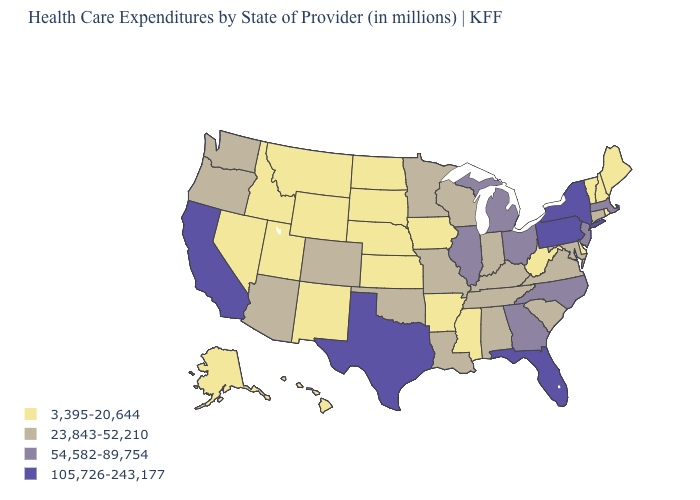Name the states that have a value in the range 105,726-243,177?
Short answer required. California, Florida, New York, Pennsylvania, Texas. Name the states that have a value in the range 3,395-20,644?
Give a very brief answer. Alaska, Arkansas, Delaware, Hawaii, Idaho, Iowa, Kansas, Maine, Mississippi, Montana, Nebraska, Nevada, New Hampshire, New Mexico, North Dakota, Rhode Island, South Dakota, Utah, Vermont, West Virginia, Wyoming. What is the value of Wyoming?
Answer briefly. 3,395-20,644. Which states have the lowest value in the USA?
Answer briefly. Alaska, Arkansas, Delaware, Hawaii, Idaho, Iowa, Kansas, Maine, Mississippi, Montana, Nebraska, Nevada, New Hampshire, New Mexico, North Dakota, Rhode Island, South Dakota, Utah, Vermont, West Virginia, Wyoming. Name the states that have a value in the range 3,395-20,644?
Give a very brief answer. Alaska, Arkansas, Delaware, Hawaii, Idaho, Iowa, Kansas, Maine, Mississippi, Montana, Nebraska, Nevada, New Hampshire, New Mexico, North Dakota, Rhode Island, South Dakota, Utah, Vermont, West Virginia, Wyoming. Does the first symbol in the legend represent the smallest category?
Short answer required. Yes. Which states have the lowest value in the South?
Be succinct. Arkansas, Delaware, Mississippi, West Virginia. Name the states that have a value in the range 54,582-89,754?
Short answer required. Georgia, Illinois, Massachusetts, Michigan, New Jersey, North Carolina, Ohio. Name the states that have a value in the range 23,843-52,210?
Give a very brief answer. Alabama, Arizona, Colorado, Connecticut, Indiana, Kentucky, Louisiana, Maryland, Minnesota, Missouri, Oklahoma, Oregon, South Carolina, Tennessee, Virginia, Washington, Wisconsin. What is the lowest value in the USA?
Concise answer only. 3,395-20,644. Does the map have missing data?
Short answer required. No. Does Arkansas have the lowest value in the South?
Short answer required. Yes. What is the value of Idaho?
Quick response, please. 3,395-20,644. What is the value of Idaho?
Be succinct. 3,395-20,644. Among the states that border Pennsylvania , which have the lowest value?
Be succinct. Delaware, West Virginia. 